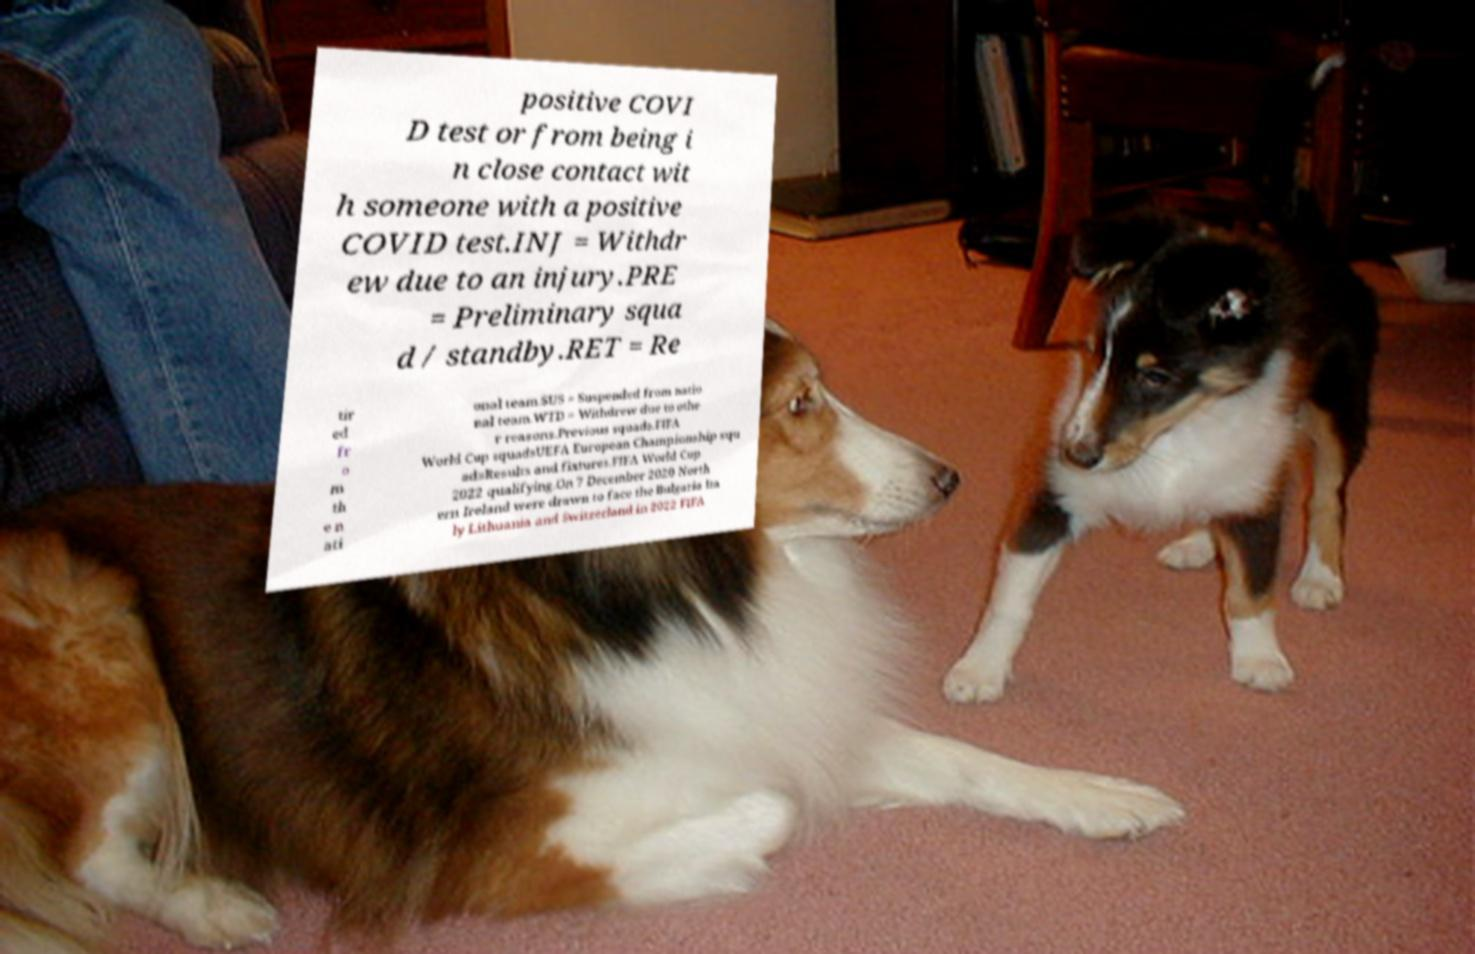Can you accurately transcribe the text from the provided image for me? positive COVI D test or from being i n close contact wit h someone with a positive COVID test.INJ = Withdr ew due to an injury.PRE = Preliminary squa d / standby.RET = Re tir ed fr o m th e n ati onal team.SUS = Suspended from natio nal team.WTD = Withdrew due to othe r reasons.Previous squads.FIFA World Cup squadsUEFA European Championship squ adsResults and fixtures.FIFA World Cup 2022 qualifying.On 7 December 2020 North ern Ireland were drawn to face the Bulgaria Ita ly Lithuania and Switzerland in 2022 FIFA 